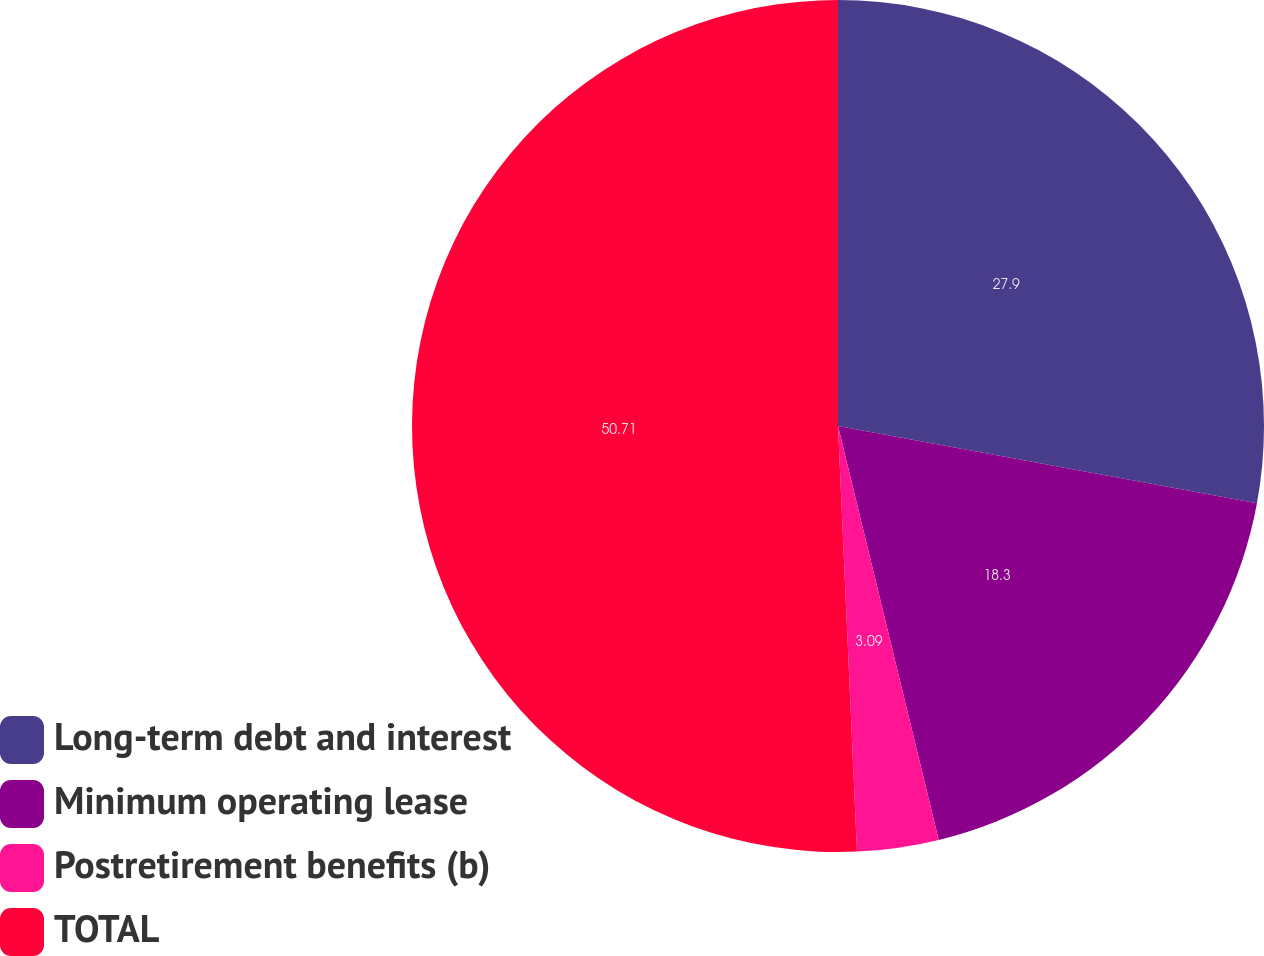Convert chart. <chart><loc_0><loc_0><loc_500><loc_500><pie_chart><fcel>Long-term debt and interest<fcel>Minimum operating lease<fcel>Postretirement benefits (b)<fcel>TOTAL<nl><fcel>27.9%<fcel>18.3%<fcel>3.09%<fcel>50.71%<nl></chart> 